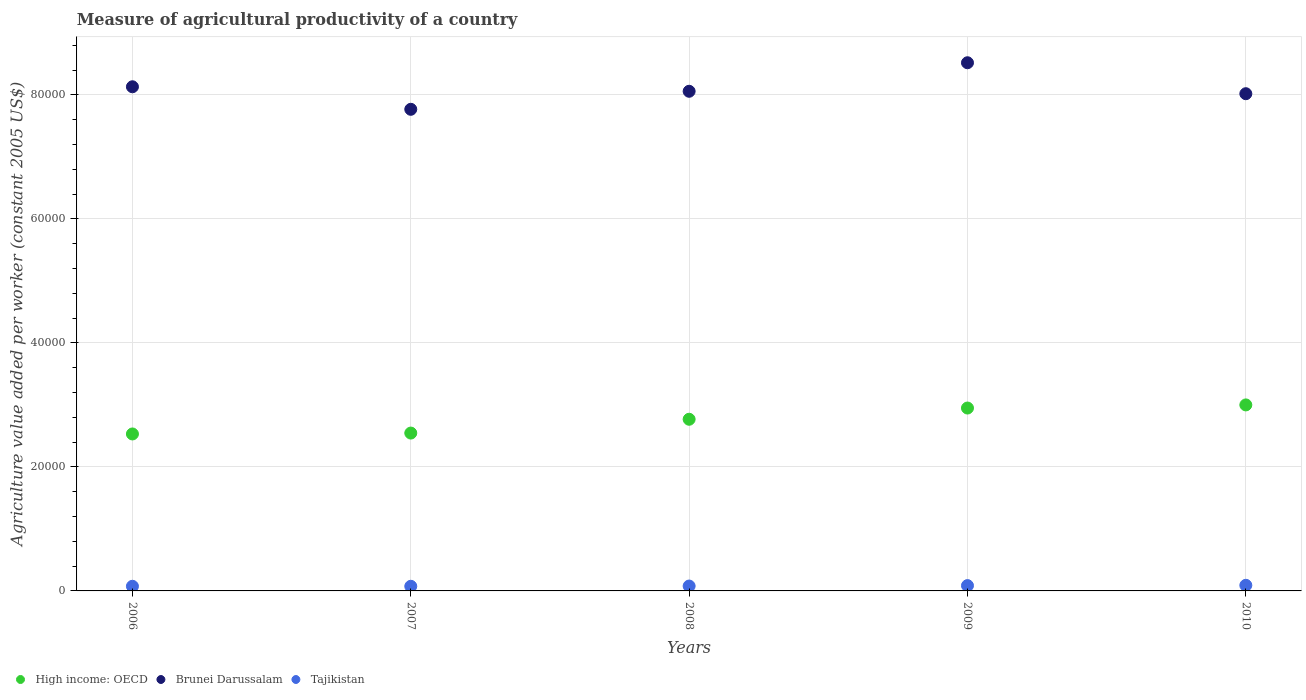What is the measure of agricultural productivity in Tajikistan in 2008?
Provide a succinct answer. 788.51. Across all years, what is the maximum measure of agricultural productivity in High income: OECD?
Provide a succinct answer. 3.00e+04. Across all years, what is the minimum measure of agricultural productivity in Brunei Darussalam?
Provide a short and direct response. 7.77e+04. In which year was the measure of agricultural productivity in Tajikistan maximum?
Keep it short and to the point. 2010. In which year was the measure of agricultural productivity in Brunei Darussalam minimum?
Your response must be concise. 2007. What is the total measure of agricultural productivity in High income: OECD in the graph?
Your answer should be very brief. 1.38e+05. What is the difference between the measure of agricultural productivity in Tajikistan in 2007 and that in 2008?
Your response must be concise. -41.15. What is the difference between the measure of agricultural productivity in High income: OECD in 2006 and the measure of agricultural productivity in Brunei Darussalam in 2007?
Make the answer very short. -5.24e+04. What is the average measure of agricultural productivity in Tajikistan per year?
Keep it short and to the point. 809.68. In the year 2007, what is the difference between the measure of agricultural productivity in Brunei Darussalam and measure of agricultural productivity in High income: OECD?
Offer a terse response. 5.22e+04. What is the ratio of the measure of agricultural productivity in High income: OECD in 2006 to that in 2010?
Keep it short and to the point. 0.84. What is the difference between the highest and the second highest measure of agricultural productivity in Tajikistan?
Give a very brief answer. 47.65. What is the difference between the highest and the lowest measure of agricultural productivity in Tajikistan?
Ensure brevity in your answer.  157.91. In how many years, is the measure of agricultural productivity in Brunei Darussalam greater than the average measure of agricultural productivity in Brunei Darussalam taken over all years?
Make the answer very short. 2. Is the sum of the measure of agricultural productivity in High income: OECD in 2006 and 2008 greater than the maximum measure of agricultural productivity in Brunei Darussalam across all years?
Make the answer very short. No. Is it the case that in every year, the sum of the measure of agricultural productivity in Brunei Darussalam and measure of agricultural productivity in High income: OECD  is greater than the measure of agricultural productivity in Tajikistan?
Make the answer very short. Yes. Is the measure of agricultural productivity in Brunei Darussalam strictly greater than the measure of agricultural productivity in Tajikistan over the years?
Your response must be concise. Yes. Is the measure of agricultural productivity in Brunei Darussalam strictly less than the measure of agricultural productivity in Tajikistan over the years?
Keep it short and to the point. No. How many dotlines are there?
Offer a very short reply. 3. How many years are there in the graph?
Give a very brief answer. 5. Are the values on the major ticks of Y-axis written in scientific E-notation?
Your answer should be compact. No. Where does the legend appear in the graph?
Your answer should be compact. Bottom left. What is the title of the graph?
Make the answer very short. Measure of agricultural productivity of a country. Does "Equatorial Guinea" appear as one of the legend labels in the graph?
Your response must be concise. No. What is the label or title of the X-axis?
Your answer should be compact. Years. What is the label or title of the Y-axis?
Your response must be concise. Agriculture value added per worker (constant 2005 US$). What is the Agriculture value added per worker (constant 2005 US$) of High income: OECD in 2006?
Your response must be concise. 2.53e+04. What is the Agriculture value added per worker (constant 2005 US$) of Brunei Darussalam in 2006?
Your answer should be very brief. 8.13e+04. What is the Agriculture value added per worker (constant 2005 US$) of Tajikistan in 2006?
Keep it short and to the point. 749.62. What is the Agriculture value added per worker (constant 2005 US$) of High income: OECD in 2007?
Your answer should be very brief. 2.55e+04. What is the Agriculture value added per worker (constant 2005 US$) of Brunei Darussalam in 2007?
Provide a short and direct response. 7.77e+04. What is the Agriculture value added per worker (constant 2005 US$) of Tajikistan in 2007?
Offer a terse response. 747.36. What is the Agriculture value added per worker (constant 2005 US$) in High income: OECD in 2008?
Provide a short and direct response. 2.77e+04. What is the Agriculture value added per worker (constant 2005 US$) in Brunei Darussalam in 2008?
Make the answer very short. 8.06e+04. What is the Agriculture value added per worker (constant 2005 US$) of Tajikistan in 2008?
Offer a terse response. 788.51. What is the Agriculture value added per worker (constant 2005 US$) of High income: OECD in 2009?
Keep it short and to the point. 2.95e+04. What is the Agriculture value added per worker (constant 2005 US$) of Brunei Darussalam in 2009?
Offer a terse response. 8.52e+04. What is the Agriculture value added per worker (constant 2005 US$) of Tajikistan in 2009?
Give a very brief answer. 857.62. What is the Agriculture value added per worker (constant 2005 US$) of High income: OECD in 2010?
Offer a very short reply. 3.00e+04. What is the Agriculture value added per worker (constant 2005 US$) of Brunei Darussalam in 2010?
Your answer should be very brief. 8.02e+04. What is the Agriculture value added per worker (constant 2005 US$) of Tajikistan in 2010?
Keep it short and to the point. 905.28. Across all years, what is the maximum Agriculture value added per worker (constant 2005 US$) in High income: OECD?
Provide a succinct answer. 3.00e+04. Across all years, what is the maximum Agriculture value added per worker (constant 2005 US$) of Brunei Darussalam?
Offer a terse response. 8.52e+04. Across all years, what is the maximum Agriculture value added per worker (constant 2005 US$) in Tajikistan?
Give a very brief answer. 905.28. Across all years, what is the minimum Agriculture value added per worker (constant 2005 US$) of High income: OECD?
Keep it short and to the point. 2.53e+04. Across all years, what is the minimum Agriculture value added per worker (constant 2005 US$) in Brunei Darussalam?
Your response must be concise. 7.77e+04. Across all years, what is the minimum Agriculture value added per worker (constant 2005 US$) in Tajikistan?
Provide a short and direct response. 747.36. What is the total Agriculture value added per worker (constant 2005 US$) of High income: OECD in the graph?
Provide a succinct answer. 1.38e+05. What is the total Agriculture value added per worker (constant 2005 US$) of Brunei Darussalam in the graph?
Ensure brevity in your answer.  4.05e+05. What is the total Agriculture value added per worker (constant 2005 US$) in Tajikistan in the graph?
Provide a succinct answer. 4048.39. What is the difference between the Agriculture value added per worker (constant 2005 US$) in High income: OECD in 2006 and that in 2007?
Make the answer very short. -143.81. What is the difference between the Agriculture value added per worker (constant 2005 US$) in Brunei Darussalam in 2006 and that in 2007?
Provide a short and direct response. 3633.24. What is the difference between the Agriculture value added per worker (constant 2005 US$) of Tajikistan in 2006 and that in 2007?
Provide a short and direct response. 2.26. What is the difference between the Agriculture value added per worker (constant 2005 US$) in High income: OECD in 2006 and that in 2008?
Offer a very short reply. -2370.76. What is the difference between the Agriculture value added per worker (constant 2005 US$) of Brunei Darussalam in 2006 and that in 2008?
Provide a short and direct response. 726.65. What is the difference between the Agriculture value added per worker (constant 2005 US$) of Tajikistan in 2006 and that in 2008?
Give a very brief answer. -38.9. What is the difference between the Agriculture value added per worker (constant 2005 US$) in High income: OECD in 2006 and that in 2009?
Keep it short and to the point. -4181.64. What is the difference between the Agriculture value added per worker (constant 2005 US$) in Brunei Darussalam in 2006 and that in 2009?
Keep it short and to the point. -3875.46. What is the difference between the Agriculture value added per worker (constant 2005 US$) of Tajikistan in 2006 and that in 2009?
Your response must be concise. -108. What is the difference between the Agriculture value added per worker (constant 2005 US$) of High income: OECD in 2006 and that in 2010?
Give a very brief answer. -4684.43. What is the difference between the Agriculture value added per worker (constant 2005 US$) of Brunei Darussalam in 2006 and that in 2010?
Give a very brief answer. 1118.43. What is the difference between the Agriculture value added per worker (constant 2005 US$) in Tajikistan in 2006 and that in 2010?
Your answer should be very brief. -155.66. What is the difference between the Agriculture value added per worker (constant 2005 US$) in High income: OECD in 2007 and that in 2008?
Give a very brief answer. -2226.95. What is the difference between the Agriculture value added per worker (constant 2005 US$) in Brunei Darussalam in 2007 and that in 2008?
Provide a succinct answer. -2906.6. What is the difference between the Agriculture value added per worker (constant 2005 US$) in Tajikistan in 2007 and that in 2008?
Provide a short and direct response. -41.15. What is the difference between the Agriculture value added per worker (constant 2005 US$) of High income: OECD in 2007 and that in 2009?
Provide a succinct answer. -4037.83. What is the difference between the Agriculture value added per worker (constant 2005 US$) of Brunei Darussalam in 2007 and that in 2009?
Your response must be concise. -7508.7. What is the difference between the Agriculture value added per worker (constant 2005 US$) in Tajikistan in 2007 and that in 2009?
Offer a very short reply. -110.26. What is the difference between the Agriculture value added per worker (constant 2005 US$) of High income: OECD in 2007 and that in 2010?
Make the answer very short. -4540.62. What is the difference between the Agriculture value added per worker (constant 2005 US$) of Brunei Darussalam in 2007 and that in 2010?
Make the answer very short. -2514.81. What is the difference between the Agriculture value added per worker (constant 2005 US$) of Tajikistan in 2007 and that in 2010?
Make the answer very short. -157.91. What is the difference between the Agriculture value added per worker (constant 2005 US$) in High income: OECD in 2008 and that in 2009?
Ensure brevity in your answer.  -1810.88. What is the difference between the Agriculture value added per worker (constant 2005 US$) in Brunei Darussalam in 2008 and that in 2009?
Make the answer very short. -4602.11. What is the difference between the Agriculture value added per worker (constant 2005 US$) of Tajikistan in 2008 and that in 2009?
Offer a very short reply. -69.11. What is the difference between the Agriculture value added per worker (constant 2005 US$) of High income: OECD in 2008 and that in 2010?
Keep it short and to the point. -2313.67. What is the difference between the Agriculture value added per worker (constant 2005 US$) of Brunei Darussalam in 2008 and that in 2010?
Offer a very short reply. 391.78. What is the difference between the Agriculture value added per worker (constant 2005 US$) in Tajikistan in 2008 and that in 2010?
Your answer should be very brief. -116.76. What is the difference between the Agriculture value added per worker (constant 2005 US$) in High income: OECD in 2009 and that in 2010?
Offer a very short reply. -502.79. What is the difference between the Agriculture value added per worker (constant 2005 US$) in Brunei Darussalam in 2009 and that in 2010?
Provide a short and direct response. 4993.89. What is the difference between the Agriculture value added per worker (constant 2005 US$) of Tajikistan in 2009 and that in 2010?
Your response must be concise. -47.65. What is the difference between the Agriculture value added per worker (constant 2005 US$) in High income: OECD in 2006 and the Agriculture value added per worker (constant 2005 US$) in Brunei Darussalam in 2007?
Ensure brevity in your answer.  -5.24e+04. What is the difference between the Agriculture value added per worker (constant 2005 US$) of High income: OECD in 2006 and the Agriculture value added per worker (constant 2005 US$) of Tajikistan in 2007?
Provide a short and direct response. 2.46e+04. What is the difference between the Agriculture value added per worker (constant 2005 US$) of Brunei Darussalam in 2006 and the Agriculture value added per worker (constant 2005 US$) of Tajikistan in 2007?
Provide a succinct answer. 8.06e+04. What is the difference between the Agriculture value added per worker (constant 2005 US$) of High income: OECD in 2006 and the Agriculture value added per worker (constant 2005 US$) of Brunei Darussalam in 2008?
Keep it short and to the point. -5.53e+04. What is the difference between the Agriculture value added per worker (constant 2005 US$) of High income: OECD in 2006 and the Agriculture value added per worker (constant 2005 US$) of Tajikistan in 2008?
Give a very brief answer. 2.45e+04. What is the difference between the Agriculture value added per worker (constant 2005 US$) of Brunei Darussalam in 2006 and the Agriculture value added per worker (constant 2005 US$) of Tajikistan in 2008?
Provide a short and direct response. 8.05e+04. What is the difference between the Agriculture value added per worker (constant 2005 US$) in High income: OECD in 2006 and the Agriculture value added per worker (constant 2005 US$) in Brunei Darussalam in 2009?
Your answer should be very brief. -5.99e+04. What is the difference between the Agriculture value added per worker (constant 2005 US$) in High income: OECD in 2006 and the Agriculture value added per worker (constant 2005 US$) in Tajikistan in 2009?
Your answer should be very brief. 2.45e+04. What is the difference between the Agriculture value added per worker (constant 2005 US$) in Brunei Darussalam in 2006 and the Agriculture value added per worker (constant 2005 US$) in Tajikistan in 2009?
Ensure brevity in your answer.  8.05e+04. What is the difference between the Agriculture value added per worker (constant 2005 US$) of High income: OECD in 2006 and the Agriculture value added per worker (constant 2005 US$) of Brunei Darussalam in 2010?
Your answer should be very brief. -5.49e+04. What is the difference between the Agriculture value added per worker (constant 2005 US$) in High income: OECD in 2006 and the Agriculture value added per worker (constant 2005 US$) in Tajikistan in 2010?
Your response must be concise. 2.44e+04. What is the difference between the Agriculture value added per worker (constant 2005 US$) in Brunei Darussalam in 2006 and the Agriculture value added per worker (constant 2005 US$) in Tajikistan in 2010?
Offer a terse response. 8.04e+04. What is the difference between the Agriculture value added per worker (constant 2005 US$) in High income: OECD in 2007 and the Agriculture value added per worker (constant 2005 US$) in Brunei Darussalam in 2008?
Offer a terse response. -5.51e+04. What is the difference between the Agriculture value added per worker (constant 2005 US$) of High income: OECD in 2007 and the Agriculture value added per worker (constant 2005 US$) of Tajikistan in 2008?
Provide a succinct answer. 2.47e+04. What is the difference between the Agriculture value added per worker (constant 2005 US$) in Brunei Darussalam in 2007 and the Agriculture value added per worker (constant 2005 US$) in Tajikistan in 2008?
Make the answer very short. 7.69e+04. What is the difference between the Agriculture value added per worker (constant 2005 US$) of High income: OECD in 2007 and the Agriculture value added per worker (constant 2005 US$) of Brunei Darussalam in 2009?
Give a very brief answer. -5.97e+04. What is the difference between the Agriculture value added per worker (constant 2005 US$) in High income: OECD in 2007 and the Agriculture value added per worker (constant 2005 US$) in Tajikistan in 2009?
Your answer should be very brief. 2.46e+04. What is the difference between the Agriculture value added per worker (constant 2005 US$) of Brunei Darussalam in 2007 and the Agriculture value added per worker (constant 2005 US$) of Tajikistan in 2009?
Offer a very short reply. 7.68e+04. What is the difference between the Agriculture value added per worker (constant 2005 US$) of High income: OECD in 2007 and the Agriculture value added per worker (constant 2005 US$) of Brunei Darussalam in 2010?
Ensure brevity in your answer.  -5.47e+04. What is the difference between the Agriculture value added per worker (constant 2005 US$) in High income: OECD in 2007 and the Agriculture value added per worker (constant 2005 US$) in Tajikistan in 2010?
Keep it short and to the point. 2.46e+04. What is the difference between the Agriculture value added per worker (constant 2005 US$) of Brunei Darussalam in 2007 and the Agriculture value added per worker (constant 2005 US$) of Tajikistan in 2010?
Your answer should be compact. 7.68e+04. What is the difference between the Agriculture value added per worker (constant 2005 US$) of High income: OECD in 2008 and the Agriculture value added per worker (constant 2005 US$) of Brunei Darussalam in 2009?
Provide a short and direct response. -5.75e+04. What is the difference between the Agriculture value added per worker (constant 2005 US$) in High income: OECD in 2008 and the Agriculture value added per worker (constant 2005 US$) in Tajikistan in 2009?
Your answer should be very brief. 2.68e+04. What is the difference between the Agriculture value added per worker (constant 2005 US$) in Brunei Darussalam in 2008 and the Agriculture value added per worker (constant 2005 US$) in Tajikistan in 2009?
Give a very brief answer. 7.97e+04. What is the difference between the Agriculture value added per worker (constant 2005 US$) of High income: OECD in 2008 and the Agriculture value added per worker (constant 2005 US$) of Brunei Darussalam in 2010?
Provide a short and direct response. -5.25e+04. What is the difference between the Agriculture value added per worker (constant 2005 US$) of High income: OECD in 2008 and the Agriculture value added per worker (constant 2005 US$) of Tajikistan in 2010?
Give a very brief answer. 2.68e+04. What is the difference between the Agriculture value added per worker (constant 2005 US$) in Brunei Darussalam in 2008 and the Agriculture value added per worker (constant 2005 US$) in Tajikistan in 2010?
Offer a very short reply. 7.97e+04. What is the difference between the Agriculture value added per worker (constant 2005 US$) in High income: OECD in 2009 and the Agriculture value added per worker (constant 2005 US$) in Brunei Darussalam in 2010?
Give a very brief answer. -5.07e+04. What is the difference between the Agriculture value added per worker (constant 2005 US$) in High income: OECD in 2009 and the Agriculture value added per worker (constant 2005 US$) in Tajikistan in 2010?
Offer a terse response. 2.86e+04. What is the difference between the Agriculture value added per worker (constant 2005 US$) in Brunei Darussalam in 2009 and the Agriculture value added per worker (constant 2005 US$) in Tajikistan in 2010?
Give a very brief answer. 8.43e+04. What is the average Agriculture value added per worker (constant 2005 US$) of High income: OECD per year?
Your answer should be compact. 2.76e+04. What is the average Agriculture value added per worker (constant 2005 US$) of Brunei Darussalam per year?
Ensure brevity in your answer.  8.10e+04. What is the average Agriculture value added per worker (constant 2005 US$) in Tajikistan per year?
Make the answer very short. 809.68. In the year 2006, what is the difference between the Agriculture value added per worker (constant 2005 US$) in High income: OECD and Agriculture value added per worker (constant 2005 US$) in Brunei Darussalam?
Your answer should be compact. -5.60e+04. In the year 2006, what is the difference between the Agriculture value added per worker (constant 2005 US$) of High income: OECD and Agriculture value added per worker (constant 2005 US$) of Tajikistan?
Your answer should be compact. 2.46e+04. In the year 2006, what is the difference between the Agriculture value added per worker (constant 2005 US$) of Brunei Darussalam and Agriculture value added per worker (constant 2005 US$) of Tajikistan?
Your answer should be compact. 8.06e+04. In the year 2007, what is the difference between the Agriculture value added per worker (constant 2005 US$) in High income: OECD and Agriculture value added per worker (constant 2005 US$) in Brunei Darussalam?
Offer a very short reply. -5.22e+04. In the year 2007, what is the difference between the Agriculture value added per worker (constant 2005 US$) in High income: OECD and Agriculture value added per worker (constant 2005 US$) in Tajikistan?
Your answer should be compact. 2.47e+04. In the year 2007, what is the difference between the Agriculture value added per worker (constant 2005 US$) in Brunei Darussalam and Agriculture value added per worker (constant 2005 US$) in Tajikistan?
Ensure brevity in your answer.  7.69e+04. In the year 2008, what is the difference between the Agriculture value added per worker (constant 2005 US$) of High income: OECD and Agriculture value added per worker (constant 2005 US$) of Brunei Darussalam?
Your answer should be very brief. -5.29e+04. In the year 2008, what is the difference between the Agriculture value added per worker (constant 2005 US$) in High income: OECD and Agriculture value added per worker (constant 2005 US$) in Tajikistan?
Offer a very short reply. 2.69e+04. In the year 2008, what is the difference between the Agriculture value added per worker (constant 2005 US$) of Brunei Darussalam and Agriculture value added per worker (constant 2005 US$) of Tajikistan?
Your answer should be very brief. 7.98e+04. In the year 2009, what is the difference between the Agriculture value added per worker (constant 2005 US$) in High income: OECD and Agriculture value added per worker (constant 2005 US$) in Brunei Darussalam?
Your answer should be compact. -5.57e+04. In the year 2009, what is the difference between the Agriculture value added per worker (constant 2005 US$) in High income: OECD and Agriculture value added per worker (constant 2005 US$) in Tajikistan?
Your response must be concise. 2.86e+04. In the year 2009, what is the difference between the Agriculture value added per worker (constant 2005 US$) in Brunei Darussalam and Agriculture value added per worker (constant 2005 US$) in Tajikistan?
Keep it short and to the point. 8.43e+04. In the year 2010, what is the difference between the Agriculture value added per worker (constant 2005 US$) in High income: OECD and Agriculture value added per worker (constant 2005 US$) in Brunei Darussalam?
Keep it short and to the point. -5.02e+04. In the year 2010, what is the difference between the Agriculture value added per worker (constant 2005 US$) of High income: OECD and Agriculture value added per worker (constant 2005 US$) of Tajikistan?
Provide a succinct answer. 2.91e+04. In the year 2010, what is the difference between the Agriculture value added per worker (constant 2005 US$) in Brunei Darussalam and Agriculture value added per worker (constant 2005 US$) in Tajikistan?
Your answer should be very brief. 7.93e+04. What is the ratio of the Agriculture value added per worker (constant 2005 US$) in High income: OECD in 2006 to that in 2007?
Offer a terse response. 0.99. What is the ratio of the Agriculture value added per worker (constant 2005 US$) in Brunei Darussalam in 2006 to that in 2007?
Provide a short and direct response. 1.05. What is the ratio of the Agriculture value added per worker (constant 2005 US$) of High income: OECD in 2006 to that in 2008?
Your answer should be very brief. 0.91. What is the ratio of the Agriculture value added per worker (constant 2005 US$) of Tajikistan in 2006 to that in 2008?
Offer a terse response. 0.95. What is the ratio of the Agriculture value added per worker (constant 2005 US$) of High income: OECD in 2006 to that in 2009?
Ensure brevity in your answer.  0.86. What is the ratio of the Agriculture value added per worker (constant 2005 US$) in Brunei Darussalam in 2006 to that in 2009?
Give a very brief answer. 0.95. What is the ratio of the Agriculture value added per worker (constant 2005 US$) in Tajikistan in 2006 to that in 2009?
Ensure brevity in your answer.  0.87. What is the ratio of the Agriculture value added per worker (constant 2005 US$) of High income: OECD in 2006 to that in 2010?
Offer a very short reply. 0.84. What is the ratio of the Agriculture value added per worker (constant 2005 US$) in Brunei Darussalam in 2006 to that in 2010?
Offer a very short reply. 1.01. What is the ratio of the Agriculture value added per worker (constant 2005 US$) of Tajikistan in 2006 to that in 2010?
Your answer should be very brief. 0.83. What is the ratio of the Agriculture value added per worker (constant 2005 US$) of High income: OECD in 2007 to that in 2008?
Your response must be concise. 0.92. What is the ratio of the Agriculture value added per worker (constant 2005 US$) of Brunei Darussalam in 2007 to that in 2008?
Offer a very short reply. 0.96. What is the ratio of the Agriculture value added per worker (constant 2005 US$) in Tajikistan in 2007 to that in 2008?
Make the answer very short. 0.95. What is the ratio of the Agriculture value added per worker (constant 2005 US$) in High income: OECD in 2007 to that in 2009?
Give a very brief answer. 0.86. What is the ratio of the Agriculture value added per worker (constant 2005 US$) of Brunei Darussalam in 2007 to that in 2009?
Offer a very short reply. 0.91. What is the ratio of the Agriculture value added per worker (constant 2005 US$) in Tajikistan in 2007 to that in 2009?
Your response must be concise. 0.87. What is the ratio of the Agriculture value added per worker (constant 2005 US$) of High income: OECD in 2007 to that in 2010?
Offer a very short reply. 0.85. What is the ratio of the Agriculture value added per worker (constant 2005 US$) of Brunei Darussalam in 2007 to that in 2010?
Ensure brevity in your answer.  0.97. What is the ratio of the Agriculture value added per worker (constant 2005 US$) of Tajikistan in 2007 to that in 2010?
Give a very brief answer. 0.83. What is the ratio of the Agriculture value added per worker (constant 2005 US$) in High income: OECD in 2008 to that in 2009?
Offer a very short reply. 0.94. What is the ratio of the Agriculture value added per worker (constant 2005 US$) in Brunei Darussalam in 2008 to that in 2009?
Make the answer very short. 0.95. What is the ratio of the Agriculture value added per worker (constant 2005 US$) of Tajikistan in 2008 to that in 2009?
Offer a very short reply. 0.92. What is the ratio of the Agriculture value added per worker (constant 2005 US$) of High income: OECD in 2008 to that in 2010?
Make the answer very short. 0.92. What is the ratio of the Agriculture value added per worker (constant 2005 US$) of Tajikistan in 2008 to that in 2010?
Your response must be concise. 0.87. What is the ratio of the Agriculture value added per worker (constant 2005 US$) of High income: OECD in 2009 to that in 2010?
Your answer should be very brief. 0.98. What is the ratio of the Agriculture value added per worker (constant 2005 US$) in Brunei Darussalam in 2009 to that in 2010?
Your answer should be compact. 1.06. What is the ratio of the Agriculture value added per worker (constant 2005 US$) of Tajikistan in 2009 to that in 2010?
Keep it short and to the point. 0.95. What is the difference between the highest and the second highest Agriculture value added per worker (constant 2005 US$) in High income: OECD?
Offer a very short reply. 502.79. What is the difference between the highest and the second highest Agriculture value added per worker (constant 2005 US$) of Brunei Darussalam?
Provide a succinct answer. 3875.46. What is the difference between the highest and the second highest Agriculture value added per worker (constant 2005 US$) of Tajikistan?
Your answer should be very brief. 47.65. What is the difference between the highest and the lowest Agriculture value added per worker (constant 2005 US$) of High income: OECD?
Offer a terse response. 4684.43. What is the difference between the highest and the lowest Agriculture value added per worker (constant 2005 US$) in Brunei Darussalam?
Your answer should be compact. 7508.7. What is the difference between the highest and the lowest Agriculture value added per worker (constant 2005 US$) of Tajikistan?
Keep it short and to the point. 157.91. 